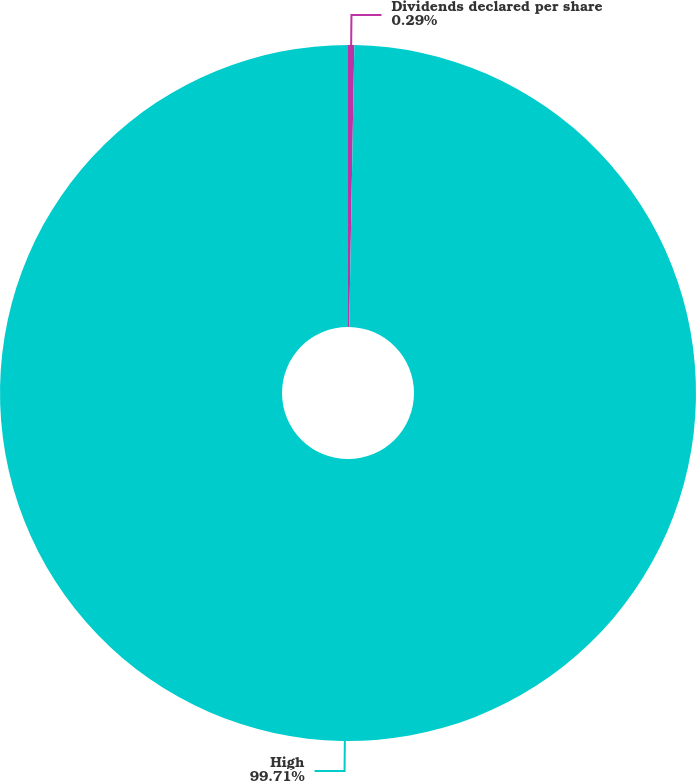<chart> <loc_0><loc_0><loc_500><loc_500><pie_chart><fcel>Dividends declared per share<fcel>High<nl><fcel>0.29%<fcel>99.71%<nl></chart> 